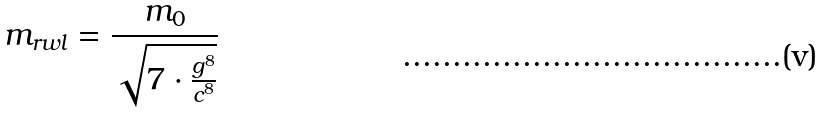<formula> <loc_0><loc_0><loc_500><loc_500>m _ { r w l } = \frac { m _ { 0 } } { \sqrt { 7 \cdot \frac { g ^ { 8 } } { c ^ { 8 } } } }</formula> 